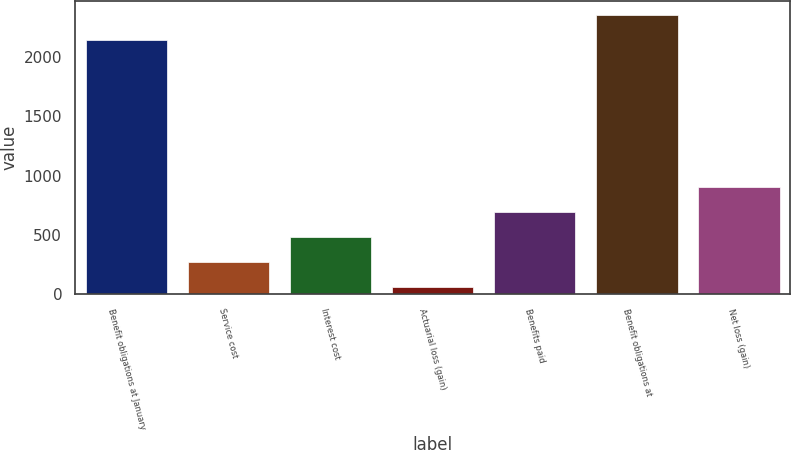Convert chart to OTSL. <chart><loc_0><loc_0><loc_500><loc_500><bar_chart><fcel>Benefit obligations at January<fcel>Service cost<fcel>Interest cost<fcel>Actuarial loss (gain)<fcel>Benefits paid<fcel>Benefit obligations at<fcel>Net loss (gain)<nl><fcel>2143<fcel>268.6<fcel>479.2<fcel>58<fcel>689.8<fcel>2353.6<fcel>900.4<nl></chart> 